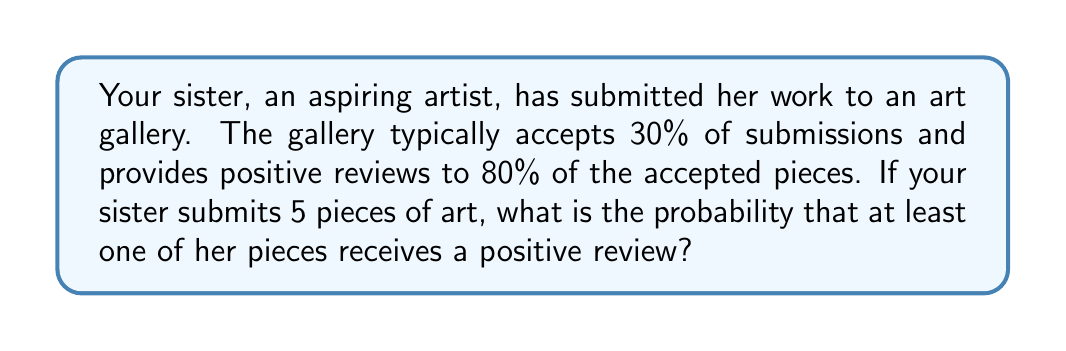Could you help me with this problem? Let's approach this step-by-step:

1) First, let's calculate the probability of a single piece receiving a positive review:
   $P(\text{positive review}) = P(\text{accepted}) \times P(\text{positive | accepted})$
   $P(\text{positive review}) = 0.30 \times 0.80 = 0.24$

2) Now, let's calculate the probability of a piece not receiving a positive review:
   $P(\text{not positive}) = 1 - P(\text{positive review}) = 1 - 0.24 = 0.76$

3) For at least one piece to receive a positive review, we can calculate the probability of not all pieces failing to receive a positive review:
   $P(\text{at least one positive}) = 1 - P(\text{all not positive})$

4) The probability of all 5 pieces not receiving a positive review:
   $P(\text{all not positive}) = 0.76^5$

5) Therefore, the probability of at least one piece receiving a positive review is:
   $P(\text{at least one positive}) = 1 - 0.76^5$

6) Calculate:
   $P(\text{at least one positive}) = 1 - 0.76^5 = 1 - 0.2373 = 0.7627$

7) Convert to a percentage:
   $0.7627 \times 100\% = 76.27\%$
Answer: $76.27\%$ 